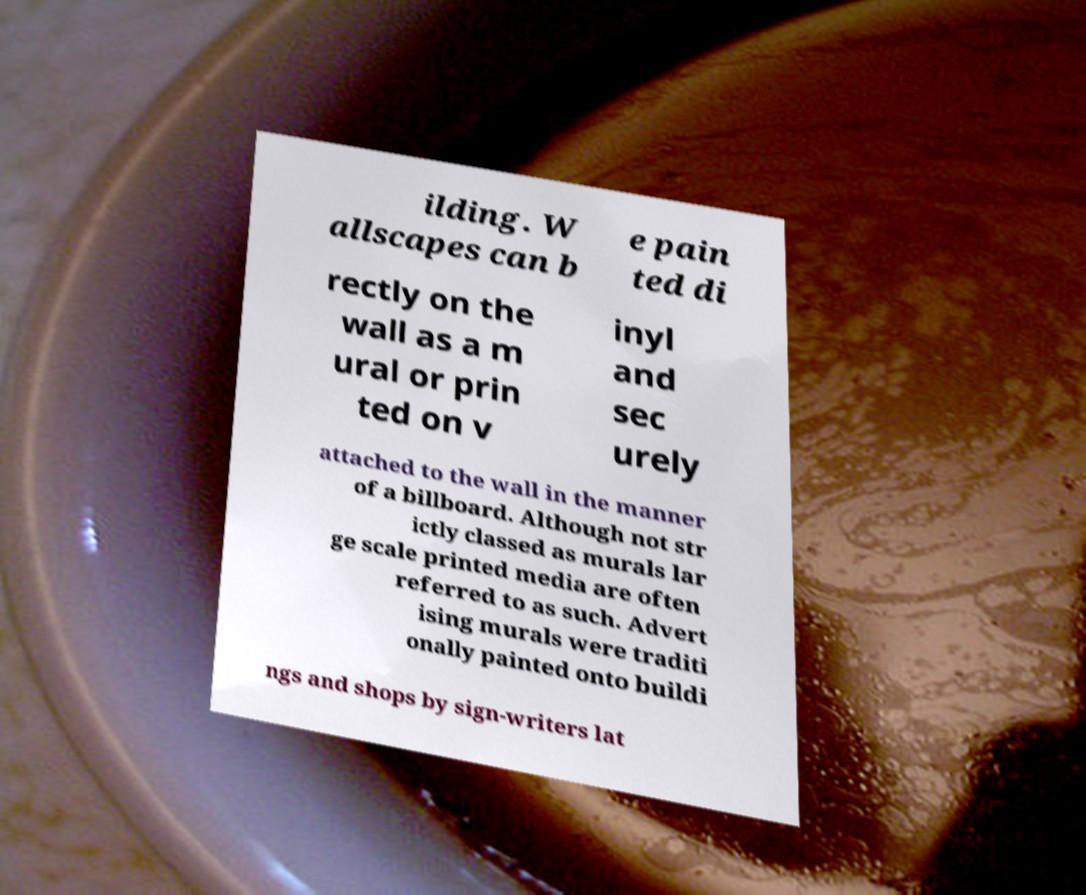Could you extract and type out the text from this image? ilding. W allscapes can b e pain ted di rectly on the wall as a m ural or prin ted on v inyl and sec urely attached to the wall in the manner of a billboard. Although not str ictly classed as murals lar ge scale printed media are often referred to as such. Advert ising murals were traditi onally painted onto buildi ngs and shops by sign-writers lat 